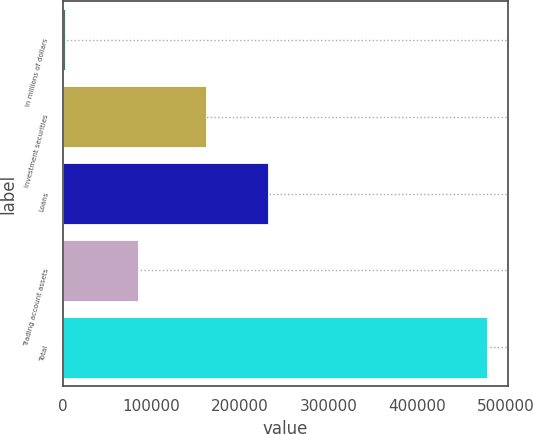Convert chart to OTSL. <chart><loc_0><loc_0><loc_500><loc_500><bar_chart><fcel>In millions of dollars<fcel>Investment securities<fcel>Loans<fcel>Trading account assets<fcel>Total<nl><fcel>2016<fcel>161914<fcel>231833<fcel>84371<fcel>478118<nl></chart> 